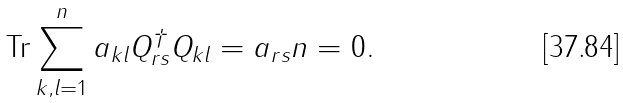Convert formula to latex. <formula><loc_0><loc_0><loc_500><loc_500>\text {Tr} \sum _ { k , l = 1 } ^ { n } a _ { k l } Q _ { r s } ^ { \dagger } Q _ { k l } = a _ { r s } n = 0 .</formula> 